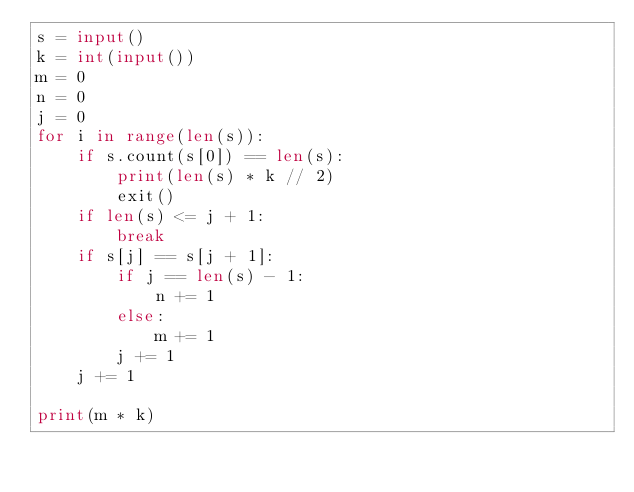Convert code to text. <code><loc_0><loc_0><loc_500><loc_500><_Python_>s = input()
k = int(input())
m = 0
n = 0
j = 0
for i in range(len(s)):
    if s.count(s[0]) == len(s):
        print(len(s) * k // 2)
        exit()
    if len(s) <= j + 1:
        break
    if s[j] == s[j + 1]:
        if j == len(s) - 1:
            n += 1
        else:
            m += 1
        j += 1
    j += 1

print(m * k)
</code> 